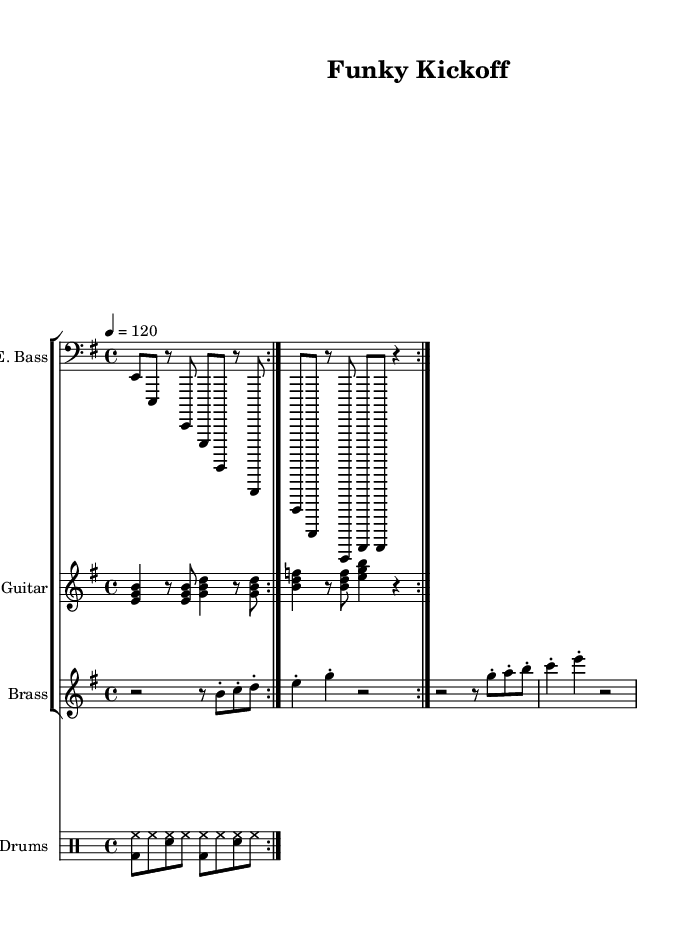What is the key signature of this music? The key signature is indicated by the number of sharps or flats at the beginning of the staff. In this case, it shows that there are no sharps or flats, placing the key in E minor.
Answer: E minor What is the time signature of this music? The time signature is usually displayed at the beginning of the sheet music, indicating how many beats are in each measure. Here, the time signature is 4/4, which means there are four beats in each measure.
Answer: 4/4 What is the tempo marking for this song? The tempo marking is specified in beats per minute. Here, it states "4 = 120," which indicates the speed at which the piece should be played.
Answer: 120 How many measures are repeated in the electric bass part? The electric bass part contains a repeat sign, which indicates that the section is played twice. By counting the parts within the repeat, we can confirm there are two measures being repeated.
Answer: 2 What type of instruments are included in this score? The score features various instrument staves, including electric bass, electric guitar, brass section, and drums. By identifying the instrument names at the start of each staff, we can list them accordingly.
Answer: Electric Bass, Electric Guitar, Brass, Drums What rhythmic element is prominent in the drums part? The drums part includes a consistent pattern where the bass drum and snare drum alternate with hi-hat, indicating a common funk rhythm. This pattern repeats throughout, underlining the funk style.
Answer: Bass drum, snare drum, hi-hat What is the primary musical technique used in the brass section? The brass section employs staccato notes, which are marked throughout the music with a dot above or below the notes. This technique adds a sharp, distinct character to the music, typical in funk arrangements.
Answer: Staccato 